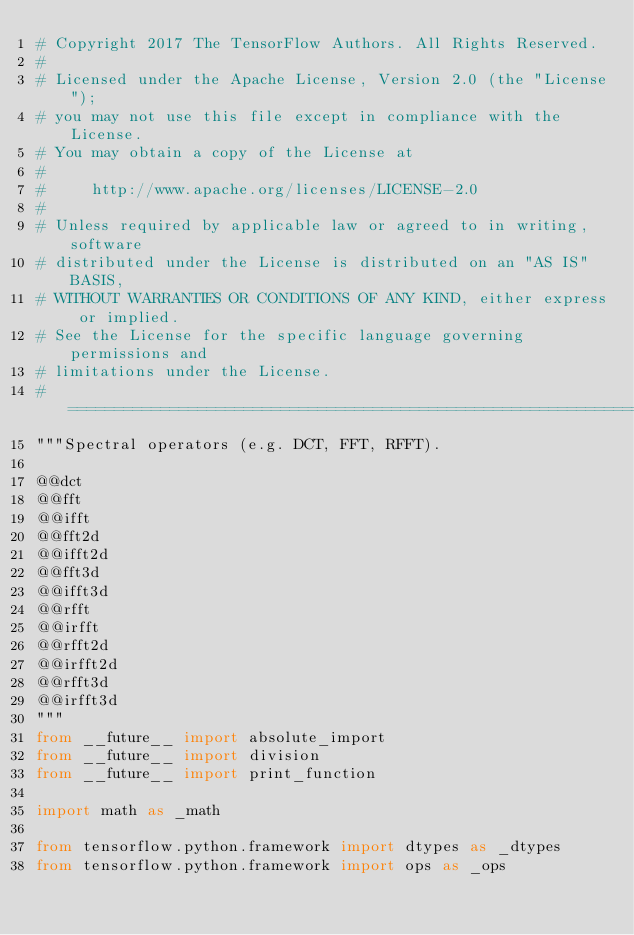<code> <loc_0><loc_0><loc_500><loc_500><_Python_># Copyright 2017 The TensorFlow Authors. All Rights Reserved.
#
# Licensed under the Apache License, Version 2.0 (the "License");
# you may not use this file except in compliance with the License.
# You may obtain a copy of the License at
#
#     http://www.apache.org/licenses/LICENSE-2.0
#
# Unless required by applicable law or agreed to in writing, software
# distributed under the License is distributed on an "AS IS" BASIS,
# WITHOUT WARRANTIES OR CONDITIONS OF ANY KIND, either express or implied.
# See the License for the specific language governing permissions and
# limitations under the License.
# ==============================================================================
"""Spectral operators (e.g. DCT, FFT, RFFT).

@@dct
@@fft
@@ifft
@@fft2d
@@ifft2d
@@fft3d
@@ifft3d
@@rfft
@@irfft
@@rfft2d
@@irfft2d
@@rfft3d
@@irfft3d
"""
from __future__ import absolute_import
from __future__ import division
from __future__ import print_function

import math as _math

from tensorflow.python.framework import dtypes as _dtypes
from tensorflow.python.framework import ops as _ops</code> 